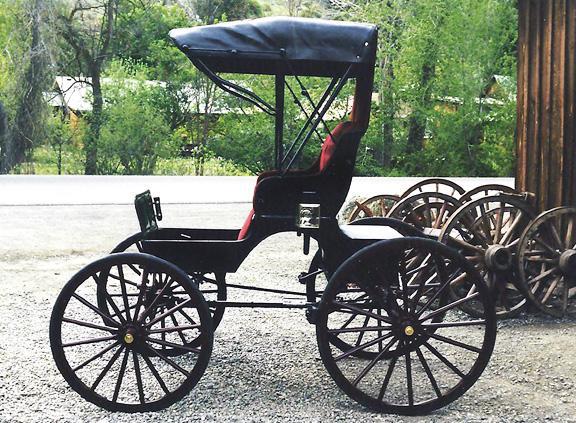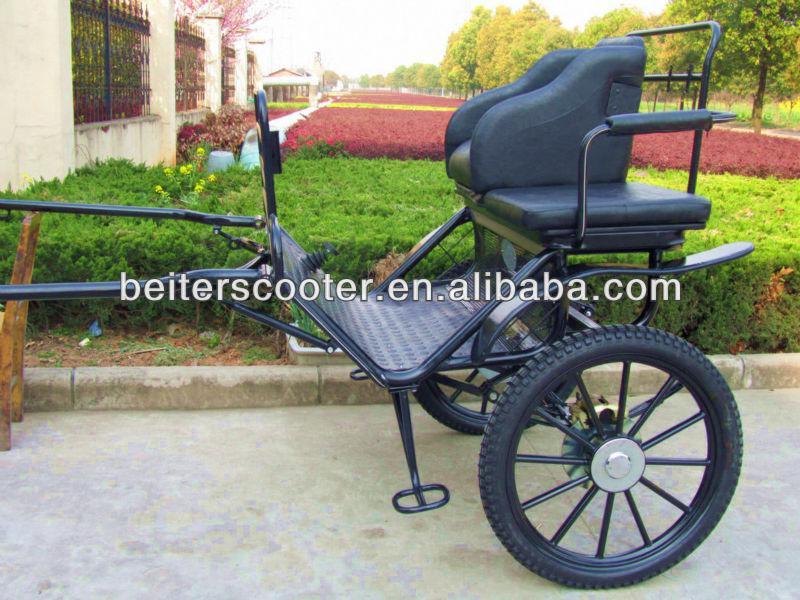The first image is the image on the left, the second image is the image on the right. Assess this claim about the two images: "At least one buggy has no cover on the passenger area.". Correct or not? Answer yes or no. Yes. 